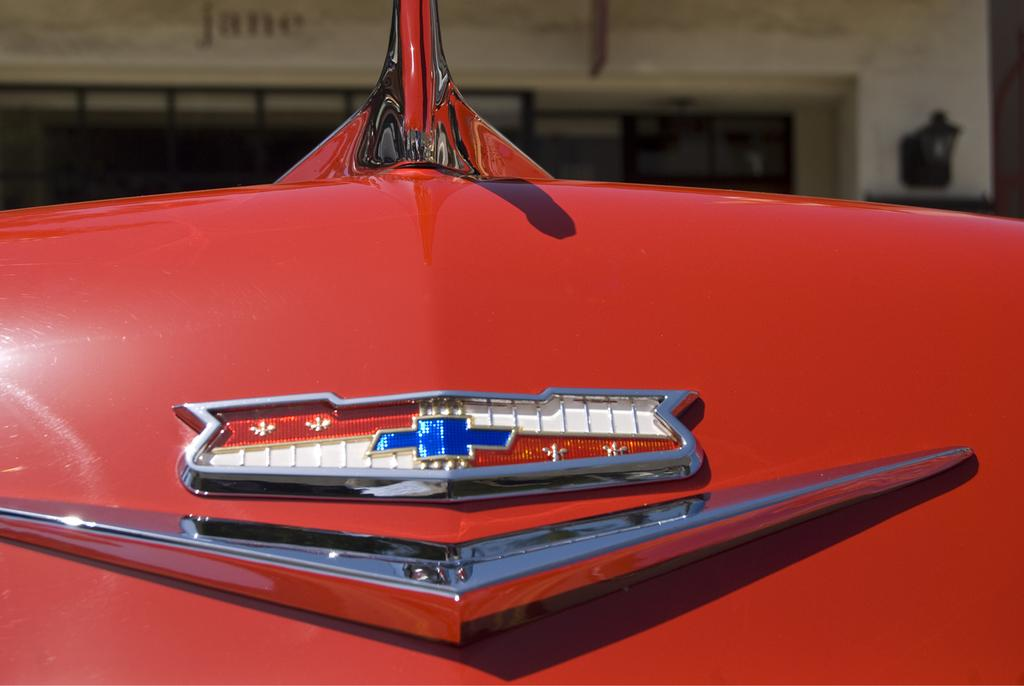What is the main subject of the image? There is a car in the image. Can you describe the color of the car? The car is red in color. What type of pancake is being served under the umbrella in the image? There is no umbrella or pancake present in the image; it only features a red car. 